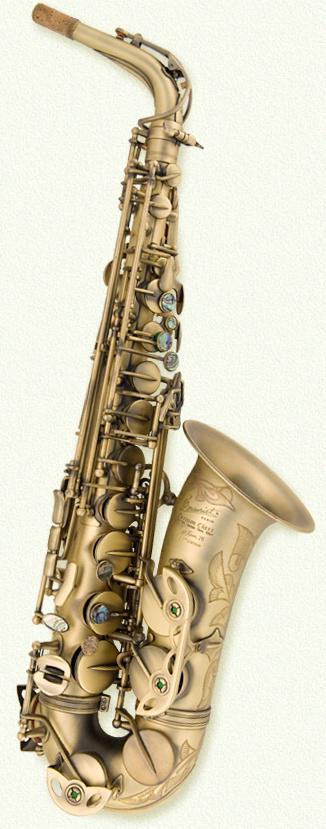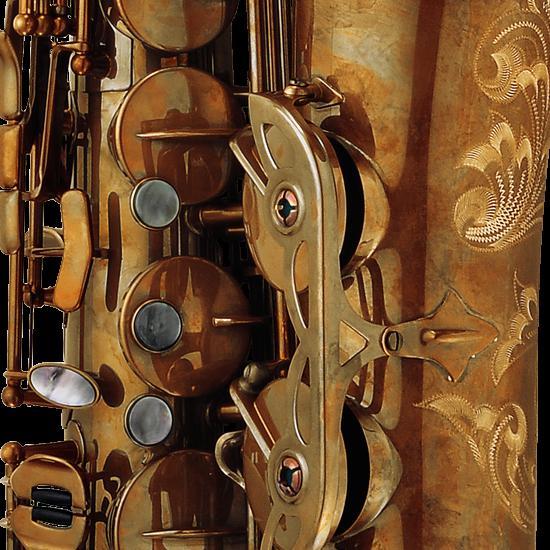The first image is the image on the left, the second image is the image on the right. Examine the images to the left and right. Is the description "In the left image, there is only one saxophone, of which you can see the entire instrument." accurate? Answer yes or no. Yes. 